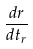<formula> <loc_0><loc_0><loc_500><loc_500>\frac { d r } { d t _ { r } }</formula> 